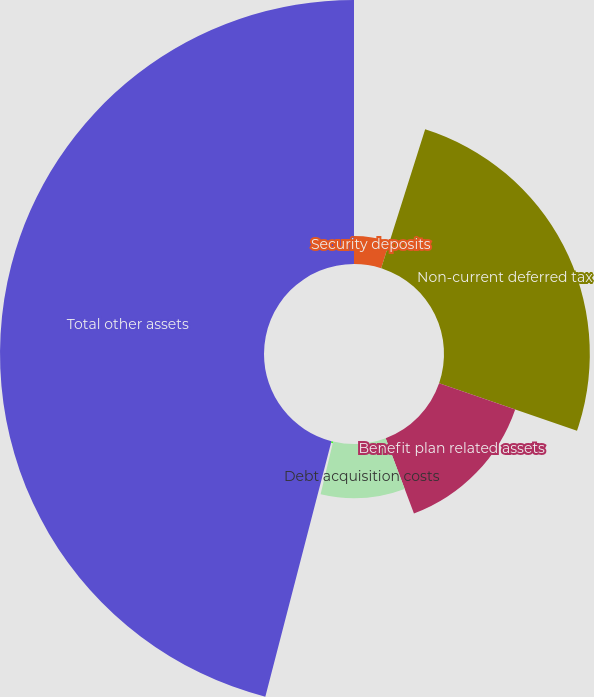Convert chart to OTSL. <chart><loc_0><loc_0><loc_500><loc_500><pie_chart><fcel>Security deposits<fcel>Non-current deferred tax<fcel>Benefit plan related assets<fcel>Debt acquisition costs<fcel>Other long-term assets<fcel>Total other assets<nl><fcel>4.88%<fcel>25.39%<fcel>14.01%<fcel>9.44%<fcel>0.31%<fcel>45.97%<nl></chart> 